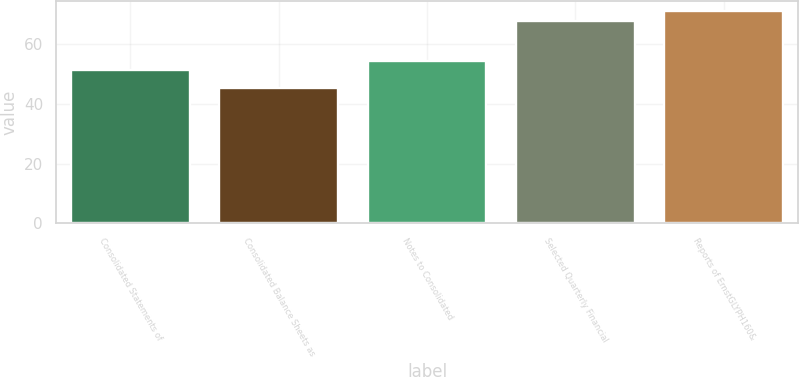<chart> <loc_0><loc_0><loc_500><loc_500><bar_chart><fcel>Consolidated Statements of<fcel>Consolidated Balance Sheets as<fcel>Notes to Consolidated<fcel>Selected Quarterly Financial<fcel>Reports of ErnstGLYPH160&<nl><fcel>51.4<fcel>45.2<fcel>54.5<fcel>68<fcel>71.1<nl></chart> 